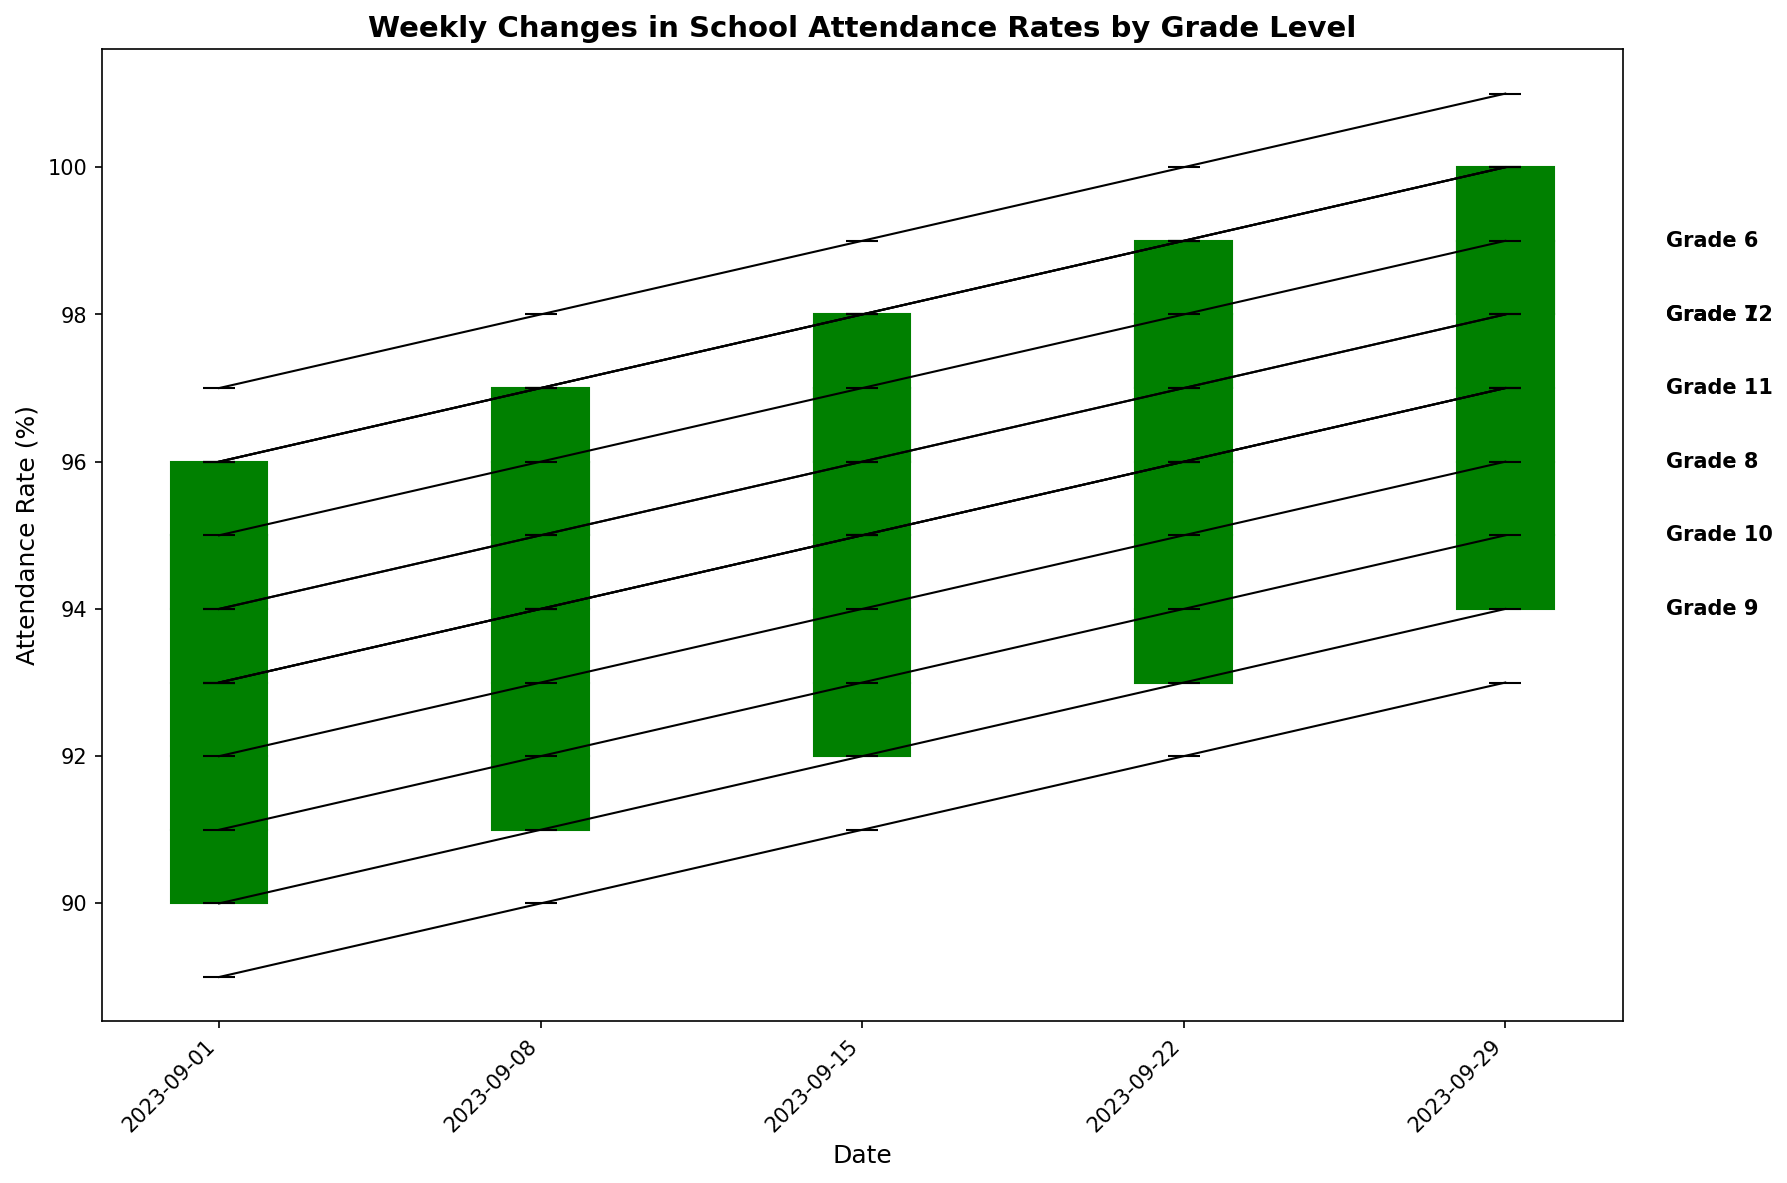Which grade had the highest attendance rate on September 22, 2023? On September 22, 2023, all grades' attendance rates can be compared by looking at their high values. Grade 6 had the highest attendance rate of 100%.
Answer: Grade 6 What is the average closing attendance rate for Grade 9 across all dates? To find the average closing rate for Grade 9, sum up the closing values (91, 92, 93, 94, 95) and divide by the number of dates (5). So, (91 + 92 + 93 + 94 + 95) / 5 = 93.
Answer: 93 Among Grades 6, 7, and 8, which had the most consistent high attendance rates across all dates? “Most consistent” means the least variation in high values. Grade 6: 97, 98, 99, 100, 101; Grade 7: 96, 97, 98, 99, 100; Grade 8: 95, 96, 97, 98, 99. Grade 7 has uniform differences between the high values.
Answer: Grade 7 How much did the closing attendance rate for Grade 11 increase from September 1, 2023, to September 29, 2023? The closing rate on September 1 was 94, and on September 29, it was 98. The increase is 98 - 94 = 4.
Answer: 4 Which grade showed the smallest change in its attendance rate (open to close) on September 15, 2023? On September 15, the difference between open and close needs to be found for each grade: Grade 6: 98 - 97 = 1, Grade 7: 97 - 96 = 1, Grade 8: 95 - 94 = 1, Grade 9: 93 - 92 = 1, Grade 10: 94 - 93 = 1, Grade 11: 96 - 95 = 1, Grade 12: 97 - 96 = 1. All grades have a change of 1.
Answer: All grades Did any grade have a decrease in closing attendance rate during the period from September 1 to September 29, 2023? By looking at the closing attendance rates over the weeks for each grade, it becomes clear that all grades show an incremental increase or remained stable over the period.
Answer: No What was the total high attendance rate for all grades combined on September 8, 2023? Add up the high values for each grade on that date: 98 (6th) + 97 (7th) + 96 (8th) + 94 (9th) + 95 (10th) + 97 (11th) + 97 (12th) = 674.
Answer: 674 Which grade experienced the greatest drop between its high and low attendance rates on September 29, 2023? The drop between high and low is calculated for each grade: Grade 6: 101 - 98 = 3, Grade 7: 100 - 97 = 3, Grade 8: 99 - 95 = 4, Grade 9: 97 - 93 = 4, Grade 10: 98 - 94 = 4, Grade 11: 100 - 96 = 4, Grade 12: 100 - 97 = 3. Grades 8, 9, 10, and 11 have the greatest drop of 4.
Answer: Grades 8, 9, 10, 11 